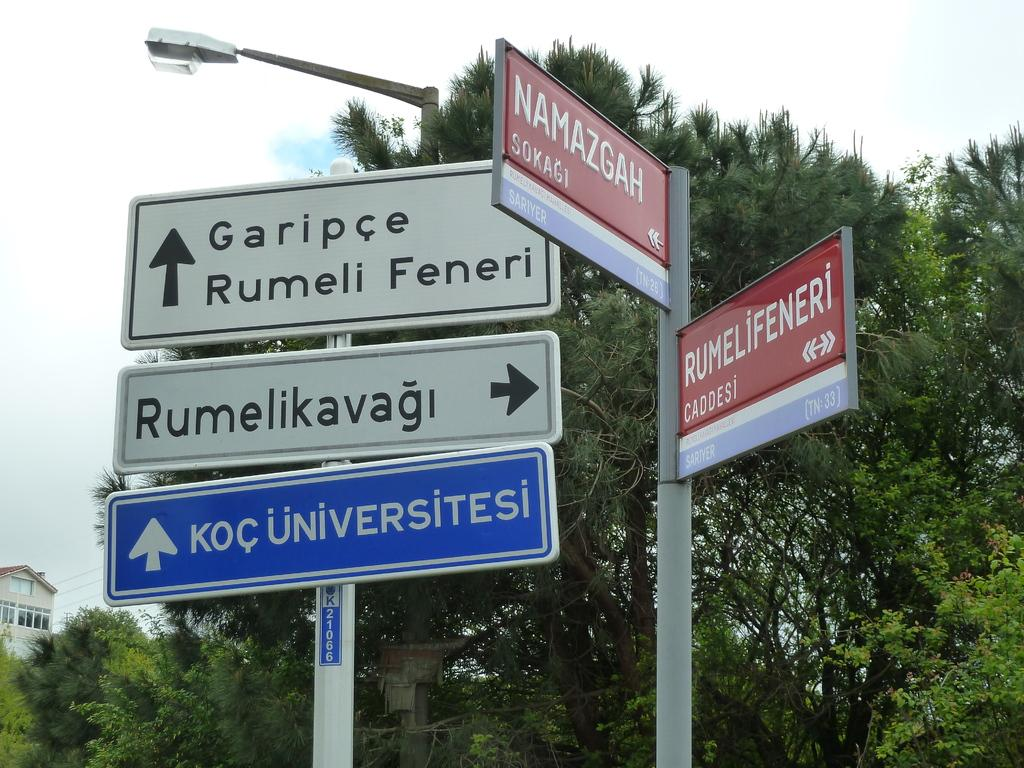<image>
Present a compact description of the photo's key features. The poles are at the intersection of Namazgah and Rumelifeneri. 